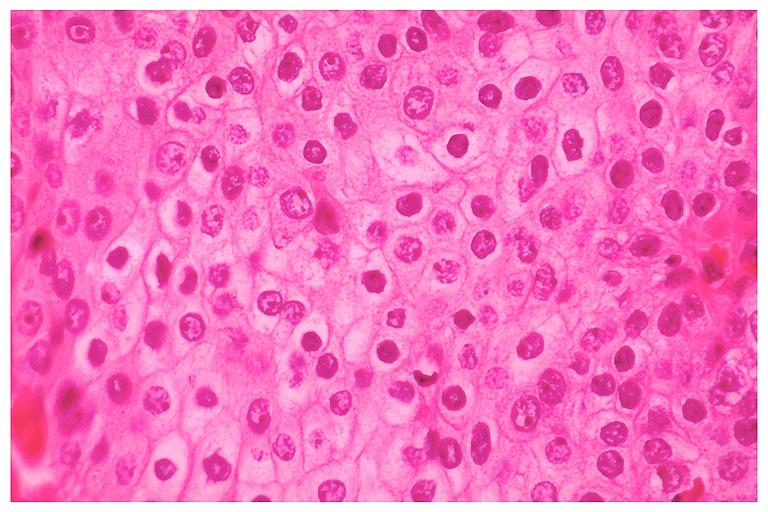does this image show mucoepidermoid carcinoma?
Answer the question using a single word or phrase. Yes 